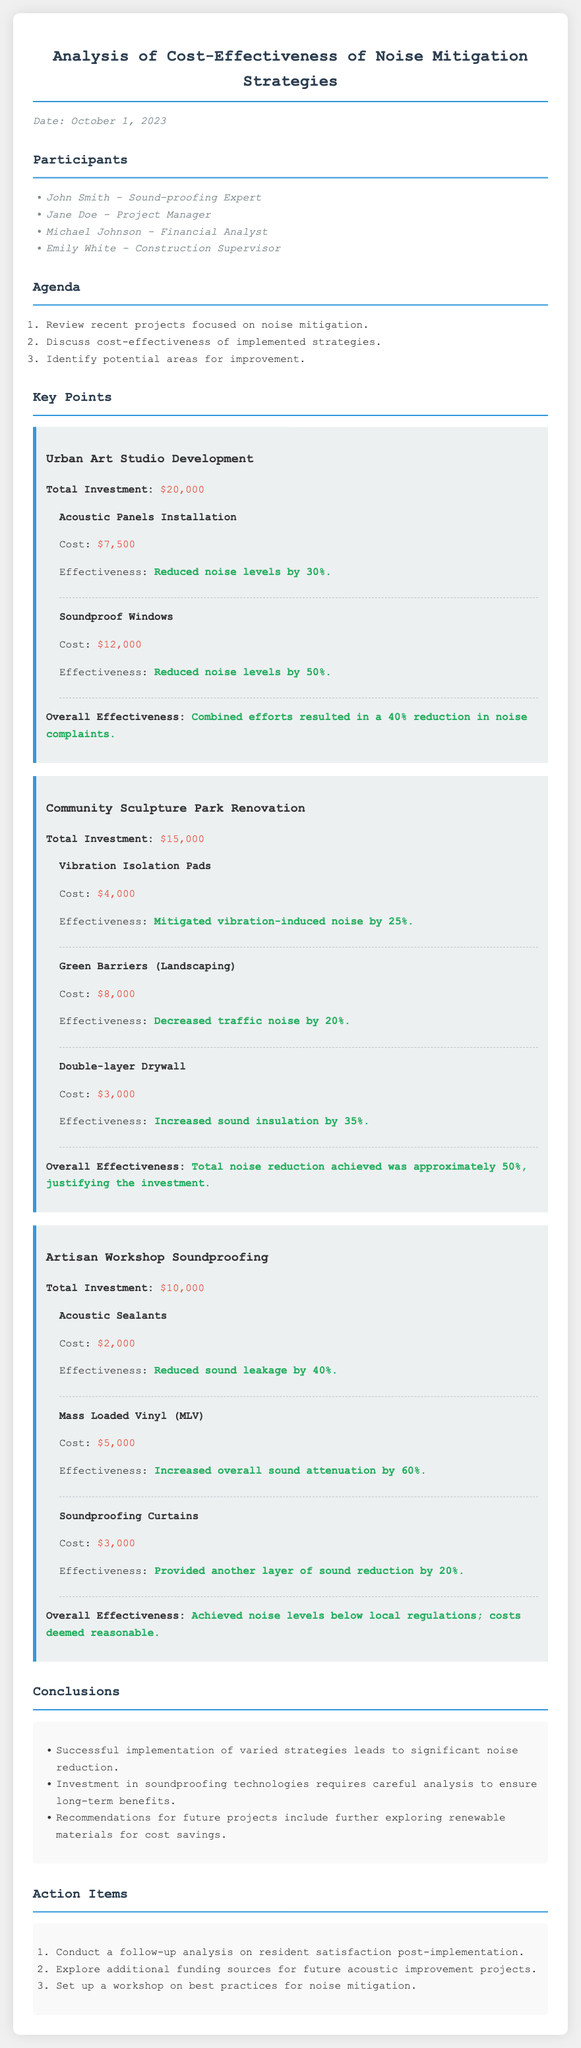What was the date of the meeting? The meeting took place on October 1, 2023, as mentioned at the top of the document.
Answer: October 1, 2023 Who was the sound-proofing expert present in the meeting? John Smith is identified as the sound-proofing expert in the participants' list.
Answer: John Smith What was the total investment for the Community Sculpture Park Renovation project? The total investment for this project is explicitly stated in the document as $15,000.
Answer: $15,000 How much did the Soundproof Windows cost? The cost of Soundproof Windows is provided within the Urban Art Studio Development section.
Answer: $12,000 What was the overall effectiveness of the Artisan Workshop Soundproofing project? The document states that the noise levels achieved were below local regulations, indicating overall effectiveness.
Answer: Achieved noise levels below local regulations How much was spent on Green Barriers in the Community Sculpture Park Renovation? The cost for Green Barriers is detailed in the project section as $8,000.
Answer: $8,000 What recommendation was made for future projects? One of the recommendations includes exploring renewable materials for potential cost savings.
Answer: Exploring renewable materials for cost savings How many strategies were implemented in the Urban Art Studio Development project? The document lists two strategies that were implemented in this project.
Answer: Two strategies What is one of the action items listed for future follow-up? The action item includes conducting a follow-up analysis on resident satisfaction post-implementation.
Answer: Conduct a follow-up analysis on resident satisfaction post-implementation 